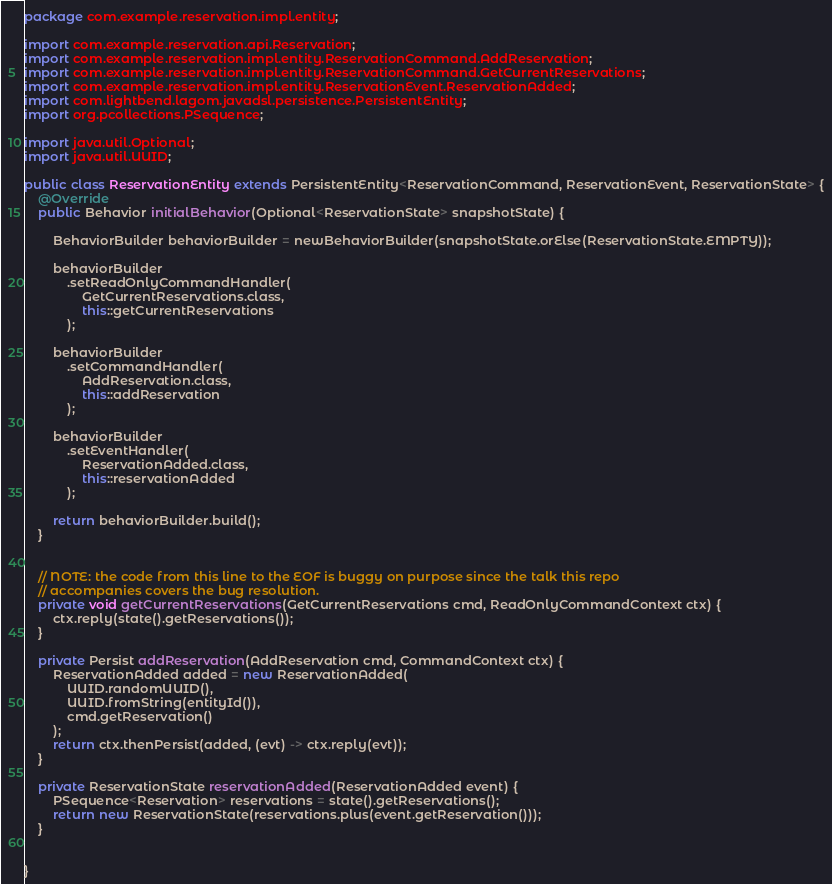Convert code to text. <code><loc_0><loc_0><loc_500><loc_500><_Java_>package com.example.reservation.impl.entity;

import com.example.reservation.api.Reservation;
import com.example.reservation.impl.entity.ReservationCommand.AddReservation;
import com.example.reservation.impl.entity.ReservationCommand.GetCurrentReservations;
import com.example.reservation.impl.entity.ReservationEvent.ReservationAdded;
import com.lightbend.lagom.javadsl.persistence.PersistentEntity;
import org.pcollections.PSequence;

import java.util.Optional;
import java.util.UUID;

public class ReservationEntity extends PersistentEntity<ReservationCommand, ReservationEvent, ReservationState> {
    @Override
    public Behavior initialBehavior(Optional<ReservationState> snapshotState) {

        BehaviorBuilder behaviorBuilder = newBehaviorBuilder(snapshotState.orElse(ReservationState.EMPTY));

        behaviorBuilder
            .setReadOnlyCommandHandler(
                GetCurrentReservations.class,
                this::getCurrentReservations
            );

        behaviorBuilder
            .setCommandHandler(
                AddReservation.class,
                this::addReservation
            );

        behaviorBuilder
            .setEventHandler(
                ReservationAdded.class,
                this::reservationAdded
            );

        return behaviorBuilder.build();
    }


    // NOTE: the code from this line to the EOF is buggy on purpose since the talk this repo
    // accompanies covers the bug resolution.
    private void getCurrentReservations(GetCurrentReservations cmd, ReadOnlyCommandContext ctx) {
        ctx.reply(state().getReservations());
    }

    private Persist addReservation(AddReservation cmd, CommandContext ctx) {
        ReservationAdded added = new ReservationAdded(
            UUID.randomUUID(),
            UUID.fromString(entityId()),
            cmd.getReservation()
        );
        return ctx.thenPersist(added, (evt) -> ctx.reply(evt));
    }

    private ReservationState reservationAdded(ReservationAdded event) {
        PSequence<Reservation> reservations = state().getReservations();
        return new ReservationState(reservations.plus(event.getReservation()));
    }


}
</code> 